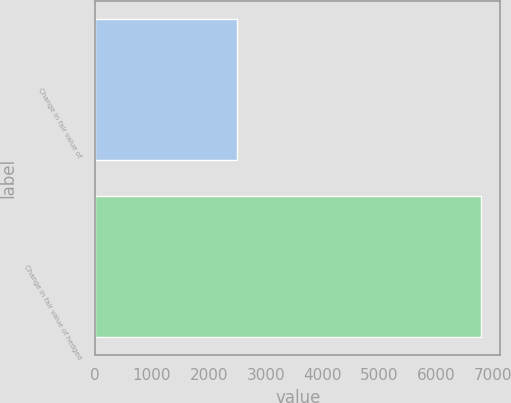Convert chart to OTSL. <chart><loc_0><loc_0><loc_500><loc_500><bar_chart><fcel>Change in fair value of<fcel>Change in fair value of hedged<nl><fcel>2493<fcel>6791.7<nl></chart> 